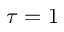Convert formula to latex. <formula><loc_0><loc_0><loc_500><loc_500>\tau = 1</formula> 